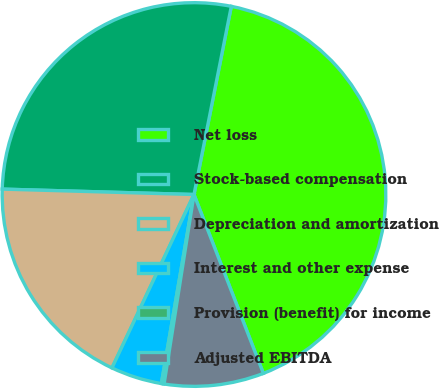<chart> <loc_0><loc_0><loc_500><loc_500><pie_chart><fcel>Net loss<fcel>Stock-based compensation<fcel>Depreciation and amortization<fcel>Interest and other expense<fcel>Provision (benefit) for income<fcel>Adjusted EBITDA<nl><fcel>41.0%<fcel>27.67%<fcel>18.42%<fcel>4.31%<fcel>0.23%<fcel>8.38%<nl></chart> 